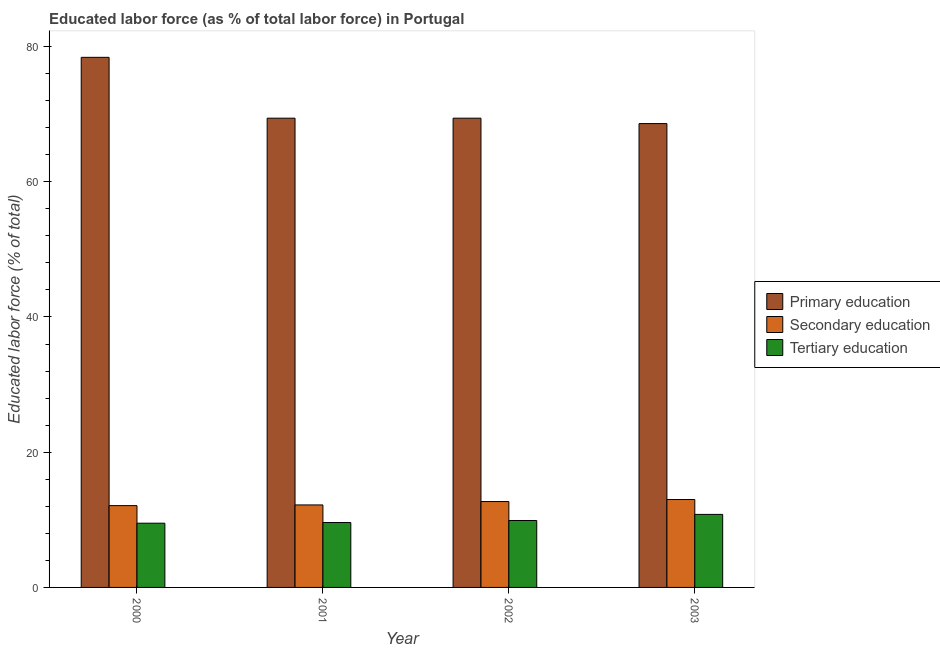Are the number of bars on each tick of the X-axis equal?
Offer a terse response. Yes. How many bars are there on the 2nd tick from the left?
Offer a very short reply. 3. How many bars are there on the 1st tick from the right?
Make the answer very short. 3. In how many cases, is the number of bars for a given year not equal to the number of legend labels?
Provide a succinct answer. 0. What is the percentage of labor force who received secondary education in 2000?
Your answer should be compact. 12.1. Across all years, what is the minimum percentage of labor force who received primary education?
Your answer should be compact. 68.6. In which year was the percentage of labor force who received primary education maximum?
Give a very brief answer. 2000. In which year was the percentage of labor force who received tertiary education minimum?
Provide a succinct answer. 2000. What is the total percentage of labor force who received tertiary education in the graph?
Offer a very short reply. 39.8. What is the difference between the percentage of labor force who received tertiary education in 2001 and that in 2002?
Offer a very short reply. -0.3. What is the difference between the percentage of labor force who received tertiary education in 2003 and the percentage of labor force who received primary education in 2002?
Your response must be concise. 0.9. What is the average percentage of labor force who received tertiary education per year?
Provide a succinct answer. 9.95. What is the ratio of the percentage of labor force who received primary education in 2000 to that in 2001?
Make the answer very short. 1.13. Is the percentage of labor force who received secondary education in 2000 less than that in 2002?
Keep it short and to the point. Yes. Is the difference between the percentage of labor force who received primary education in 2000 and 2003 greater than the difference between the percentage of labor force who received secondary education in 2000 and 2003?
Give a very brief answer. No. What is the difference between the highest and the second highest percentage of labor force who received tertiary education?
Your response must be concise. 0.9. What is the difference between the highest and the lowest percentage of labor force who received primary education?
Provide a short and direct response. 9.8. Is the sum of the percentage of labor force who received secondary education in 2000 and 2003 greater than the maximum percentage of labor force who received tertiary education across all years?
Offer a terse response. Yes. What does the 2nd bar from the left in 2002 represents?
Ensure brevity in your answer.  Secondary education. What does the 3rd bar from the right in 2002 represents?
Offer a very short reply. Primary education. Is it the case that in every year, the sum of the percentage of labor force who received primary education and percentage of labor force who received secondary education is greater than the percentage of labor force who received tertiary education?
Your answer should be very brief. Yes. Are the values on the major ticks of Y-axis written in scientific E-notation?
Your answer should be compact. No. Does the graph contain grids?
Offer a very short reply. No. How many legend labels are there?
Your answer should be very brief. 3. What is the title of the graph?
Provide a short and direct response. Educated labor force (as % of total labor force) in Portugal. What is the label or title of the X-axis?
Provide a succinct answer. Year. What is the label or title of the Y-axis?
Your response must be concise. Educated labor force (% of total). What is the Educated labor force (% of total) in Primary education in 2000?
Ensure brevity in your answer.  78.4. What is the Educated labor force (% of total) in Secondary education in 2000?
Give a very brief answer. 12.1. What is the Educated labor force (% of total) in Primary education in 2001?
Offer a terse response. 69.4. What is the Educated labor force (% of total) in Secondary education in 2001?
Ensure brevity in your answer.  12.2. What is the Educated labor force (% of total) in Tertiary education in 2001?
Your answer should be compact. 9.6. What is the Educated labor force (% of total) of Primary education in 2002?
Give a very brief answer. 69.4. What is the Educated labor force (% of total) of Secondary education in 2002?
Provide a succinct answer. 12.7. What is the Educated labor force (% of total) in Tertiary education in 2002?
Your answer should be compact. 9.9. What is the Educated labor force (% of total) of Primary education in 2003?
Provide a short and direct response. 68.6. What is the Educated labor force (% of total) in Tertiary education in 2003?
Make the answer very short. 10.8. Across all years, what is the maximum Educated labor force (% of total) in Primary education?
Make the answer very short. 78.4. Across all years, what is the maximum Educated labor force (% of total) in Secondary education?
Your answer should be very brief. 13. Across all years, what is the maximum Educated labor force (% of total) of Tertiary education?
Keep it short and to the point. 10.8. Across all years, what is the minimum Educated labor force (% of total) in Primary education?
Offer a terse response. 68.6. Across all years, what is the minimum Educated labor force (% of total) in Secondary education?
Your answer should be compact. 12.1. What is the total Educated labor force (% of total) of Primary education in the graph?
Keep it short and to the point. 285.8. What is the total Educated labor force (% of total) of Secondary education in the graph?
Make the answer very short. 50. What is the total Educated labor force (% of total) of Tertiary education in the graph?
Your response must be concise. 39.8. What is the difference between the Educated labor force (% of total) in Primary education in 2000 and that in 2001?
Your answer should be compact. 9. What is the difference between the Educated labor force (% of total) in Tertiary education in 2000 and that in 2001?
Provide a short and direct response. -0.1. What is the difference between the Educated labor force (% of total) in Tertiary education in 2000 and that in 2002?
Offer a terse response. -0.4. What is the difference between the Educated labor force (% of total) in Secondary education in 2000 and that in 2003?
Your answer should be very brief. -0.9. What is the difference between the Educated labor force (% of total) of Tertiary education in 2000 and that in 2003?
Ensure brevity in your answer.  -1.3. What is the difference between the Educated labor force (% of total) in Primary education in 2001 and that in 2002?
Your answer should be very brief. 0. What is the difference between the Educated labor force (% of total) of Secondary education in 2001 and that in 2002?
Ensure brevity in your answer.  -0.5. What is the difference between the Educated labor force (% of total) in Tertiary education in 2001 and that in 2002?
Provide a succinct answer. -0.3. What is the difference between the Educated labor force (% of total) in Secondary education in 2001 and that in 2003?
Ensure brevity in your answer.  -0.8. What is the difference between the Educated labor force (% of total) in Tertiary education in 2001 and that in 2003?
Keep it short and to the point. -1.2. What is the difference between the Educated labor force (% of total) of Primary education in 2002 and that in 2003?
Your response must be concise. 0.8. What is the difference between the Educated labor force (% of total) in Secondary education in 2002 and that in 2003?
Give a very brief answer. -0.3. What is the difference between the Educated labor force (% of total) in Tertiary education in 2002 and that in 2003?
Offer a very short reply. -0.9. What is the difference between the Educated labor force (% of total) in Primary education in 2000 and the Educated labor force (% of total) in Secondary education in 2001?
Provide a short and direct response. 66.2. What is the difference between the Educated labor force (% of total) of Primary education in 2000 and the Educated labor force (% of total) of Tertiary education in 2001?
Your answer should be compact. 68.8. What is the difference between the Educated labor force (% of total) in Secondary education in 2000 and the Educated labor force (% of total) in Tertiary education in 2001?
Provide a short and direct response. 2.5. What is the difference between the Educated labor force (% of total) in Primary education in 2000 and the Educated labor force (% of total) in Secondary education in 2002?
Offer a very short reply. 65.7. What is the difference between the Educated labor force (% of total) of Primary education in 2000 and the Educated labor force (% of total) of Tertiary education in 2002?
Make the answer very short. 68.5. What is the difference between the Educated labor force (% of total) of Secondary education in 2000 and the Educated labor force (% of total) of Tertiary education in 2002?
Ensure brevity in your answer.  2.2. What is the difference between the Educated labor force (% of total) in Primary education in 2000 and the Educated labor force (% of total) in Secondary education in 2003?
Make the answer very short. 65.4. What is the difference between the Educated labor force (% of total) in Primary education in 2000 and the Educated labor force (% of total) in Tertiary education in 2003?
Provide a short and direct response. 67.6. What is the difference between the Educated labor force (% of total) of Secondary education in 2000 and the Educated labor force (% of total) of Tertiary education in 2003?
Offer a very short reply. 1.3. What is the difference between the Educated labor force (% of total) in Primary education in 2001 and the Educated labor force (% of total) in Secondary education in 2002?
Give a very brief answer. 56.7. What is the difference between the Educated labor force (% of total) in Primary education in 2001 and the Educated labor force (% of total) in Tertiary education in 2002?
Provide a succinct answer. 59.5. What is the difference between the Educated labor force (% of total) of Primary education in 2001 and the Educated labor force (% of total) of Secondary education in 2003?
Provide a succinct answer. 56.4. What is the difference between the Educated labor force (% of total) in Primary education in 2001 and the Educated labor force (% of total) in Tertiary education in 2003?
Keep it short and to the point. 58.6. What is the difference between the Educated labor force (% of total) of Secondary education in 2001 and the Educated labor force (% of total) of Tertiary education in 2003?
Offer a very short reply. 1.4. What is the difference between the Educated labor force (% of total) in Primary education in 2002 and the Educated labor force (% of total) in Secondary education in 2003?
Offer a terse response. 56.4. What is the difference between the Educated labor force (% of total) of Primary education in 2002 and the Educated labor force (% of total) of Tertiary education in 2003?
Give a very brief answer. 58.6. What is the average Educated labor force (% of total) in Primary education per year?
Ensure brevity in your answer.  71.45. What is the average Educated labor force (% of total) in Secondary education per year?
Give a very brief answer. 12.5. What is the average Educated labor force (% of total) in Tertiary education per year?
Give a very brief answer. 9.95. In the year 2000, what is the difference between the Educated labor force (% of total) of Primary education and Educated labor force (% of total) of Secondary education?
Offer a terse response. 66.3. In the year 2000, what is the difference between the Educated labor force (% of total) of Primary education and Educated labor force (% of total) of Tertiary education?
Your answer should be compact. 68.9. In the year 2000, what is the difference between the Educated labor force (% of total) of Secondary education and Educated labor force (% of total) of Tertiary education?
Your answer should be compact. 2.6. In the year 2001, what is the difference between the Educated labor force (% of total) of Primary education and Educated labor force (% of total) of Secondary education?
Keep it short and to the point. 57.2. In the year 2001, what is the difference between the Educated labor force (% of total) in Primary education and Educated labor force (% of total) in Tertiary education?
Keep it short and to the point. 59.8. In the year 2001, what is the difference between the Educated labor force (% of total) of Secondary education and Educated labor force (% of total) of Tertiary education?
Your answer should be compact. 2.6. In the year 2002, what is the difference between the Educated labor force (% of total) in Primary education and Educated labor force (% of total) in Secondary education?
Provide a short and direct response. 56.7. In the year 2002, what is the difference between the Educated labor force (% of total) of Primary education and Educated labor force (% of total) of Tertiary education?
Your answer should be very brief. 59.5. In the year 2002, what is the difference between the Educated labor force (% of total) of Secondary education and Educated labor force (% of total) of Tertiary education?
Offer a terse response. 2.8. In the year 2003, what is the difference between the Educated labor force (% of total) of Primary education and Educated labor force (% of total) of Secondary education?
Keep it short and to the point. 55.6. In the year 2003, what is the difference between the Educated labor force (% of total) of Primary education and Educated labor force (% of total) of Tertiary education?
Provide a short and direct response. 57.8. In the year 2003, what is the difference between the Educated labor force (% of total) of Secondary education and Educated labor force (% of total) of Tertiary education?
Give a very brief answer. 2.2. What is the ratio of the Educated labor force (% of total) of Primary education in 2000 to that in 2001?
Give a very brief answer. 1.13. What is the ratio of the Educated labor force (% of total) of Secondary education in 2000 to that in 2001?
Your answer should be very brief. 0.99. What is the ratio of the Educated labor force (% of total) in Tertiary education in 2000 to that in 2001?
Ensure brevity in your answer.  0.99. What is the ratio of the Educated labor force (% of total) in Primary education in 2000 to that in 2002?
Provide a short and direct response. 1.13. What is the ratio of the Educated labor force (% of total) of Secondary education in 2000 to that in 2002?
Provide a short and direct response. 0.95. What is the ratio of the Educated labor force (% of total) in Tertiary education in 2000 to that in 2002?
Your answer should be very brief. 0.96. What is the ratio of the Educated labor force (% of total) of Secondary education in 2000 to that in 2003?
Your answer should be compact. 0.93. What is the ratio of the Educated labor force (% of total) of Tertiary education in 2000 to that in 2003?
Your response must be concise. 0.88. What is the ratio of the Educated labor force (% of total) of Secondary education in 2001 to that in 2002?
Provide a short and direct response. 0.96. What is the ratio of the Educated labor force (% of total) in Tertiary education in 2001 to that in 2002?
Make the answer very short. 0.97. What is the ratio of the Educated labor force (% of total) in Primary education in 2001 to that in 2003?
Offer a very short reply. 1.01. What is the ratio of the Educated labor force (% of total) in Secondary education in 2001 to that in 2003?
Your answer should be compact. 0.94. What is the ratio of the Educated labor force (% of total) of Tertiary education in 2001 to that in 2003?
Your response must be concise. 0.89. What is the ratio of the Educated labor force (% of total) in Primary education in 2002 to that in 2003?
Your answer should be compact. 1.01. What is the ratio of the Educated labor force (% of total) in Secondary education in 2002 to that in 2003?
Ensure brevity in your answer.  0.98. What is the difference between the highest and the second highest Educated labor force (% of total) of Primary education?
Offer a terse response. 9. What is the difference between the highest and the second highest Educated labor force (% of total) of Secondary education?
Give a very brief answer. 0.3. What is the difference between the highest and the lowest Educated labor force (% of total) in Primary education?
Your answer should be very brief. 9.8. What is the difference between the highest and the lowest Educated labor force (% of total) in Tertiary education?
Your answer should be very brief. 1.3. 